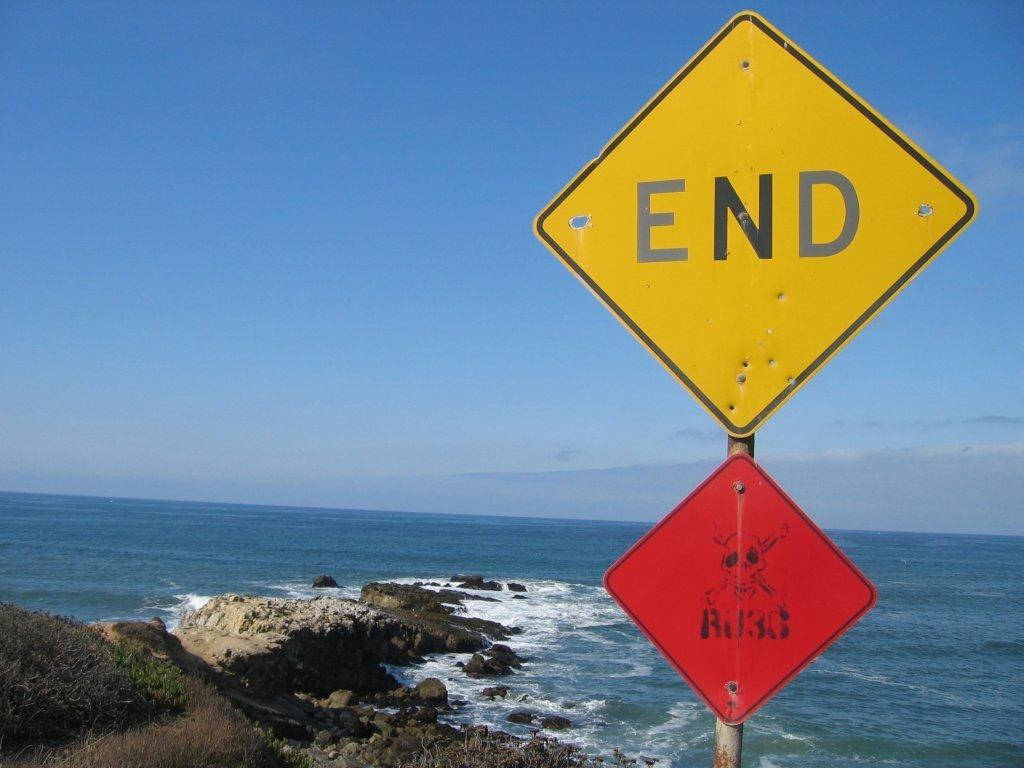<image>
Render a clear and concise summary of the photo. A large yellow sign at the beach says END and below it is a smaller red sign with a skull and cross bones on it and ilegible writing. 